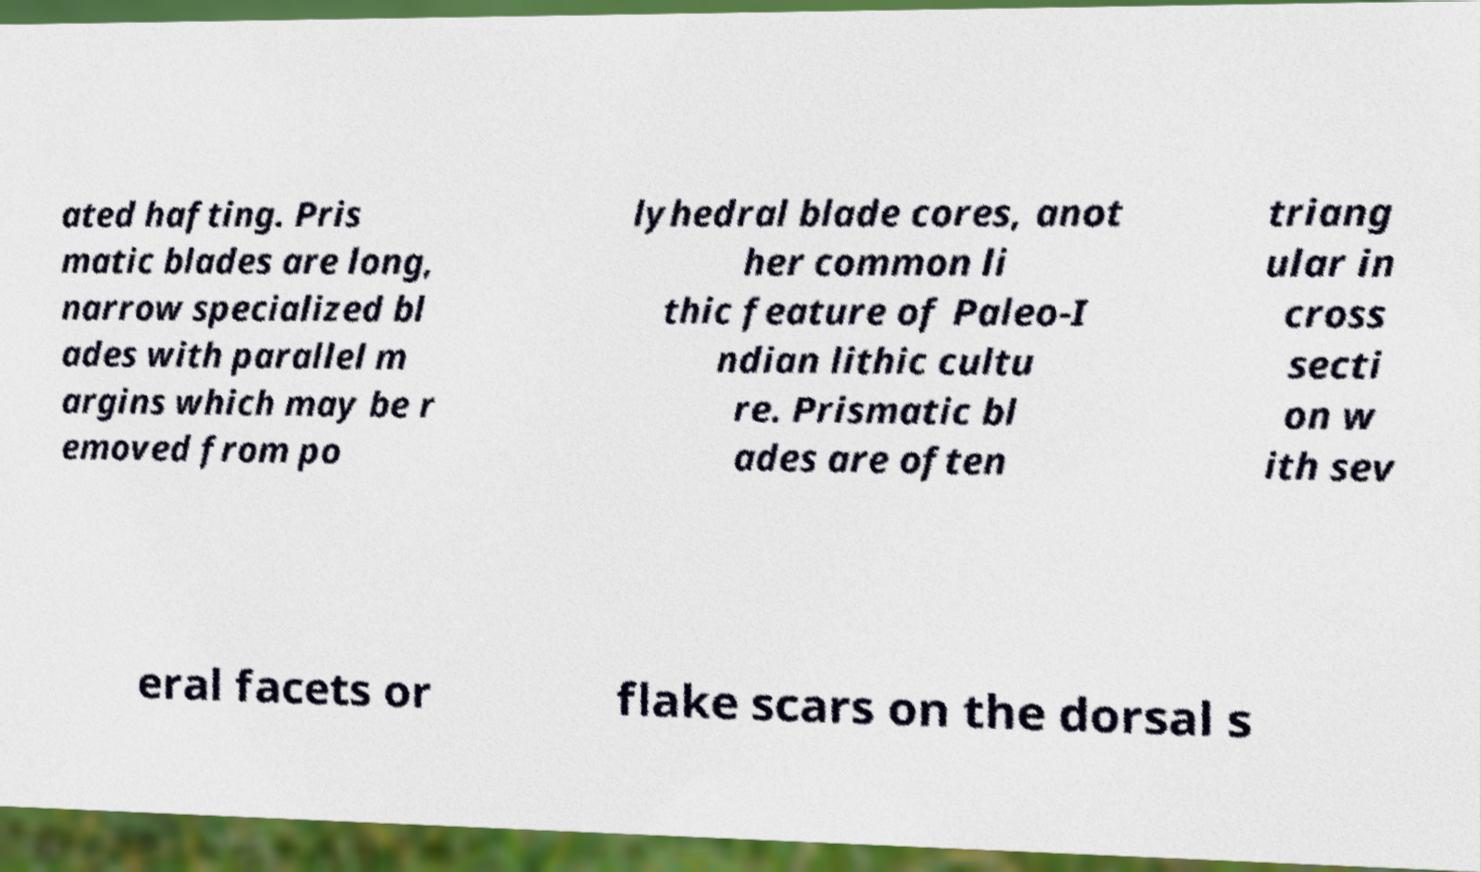I need the written content from this picture converted into text. Can you do that? ated hafting. Pris matic blades are long, narrow specialized bl ades with parallel m argins which may be r emoved from po lyhedral blade cores, anot her common li thic feature of Paleo-I ndian lithic cultu re. Prismatic bl ades are often triang ular in cross secti on w ith sev eral facets or flake scars on the dorsal s 